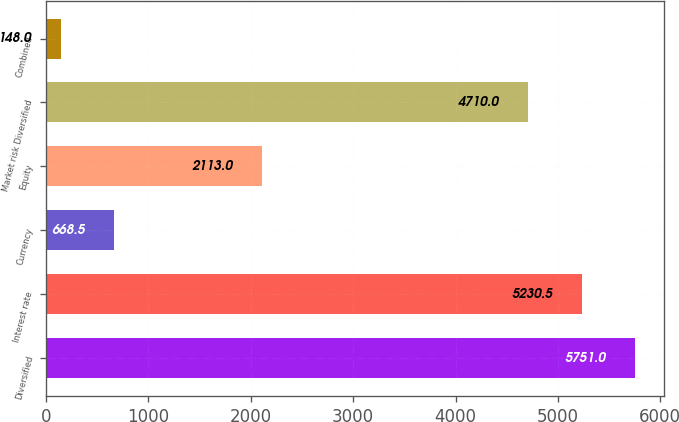Convert chart. <chart><loc_0><loc_0><loc_500><loc_500><bar_chart><fcel>Diversified<fcel>Interest rate<fcel>Currency<fcel>Equity<fcel>Market risk Diversified<fcel>Combined<nl><fcel>5751<fcel>5230.5<fcel>668.5<fcel>2113<fcel>4710<fcel>148<nl></chart> 